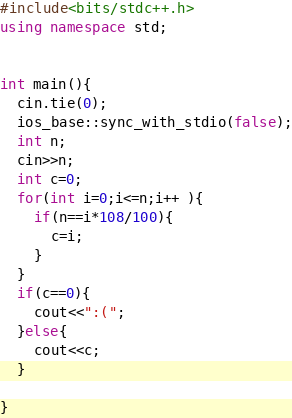<code> <loc_0><loc_0><loc_500><loc_500><_C++_>#include<bits/stdc++.h>
using namespace std;


int main(){
  cin.tie(0);
  ios_base::sync_with_stdio(false);
  int n;
  cin>>n;
  int c=0;
  for(int i=0;i<=n;i++ ){
    if(n==i*108/100){
      c=i;
    }
  }
  if(c==0){
    cout<<":(";
  }else{
    cout<<c;
  }
  
}

</code> 